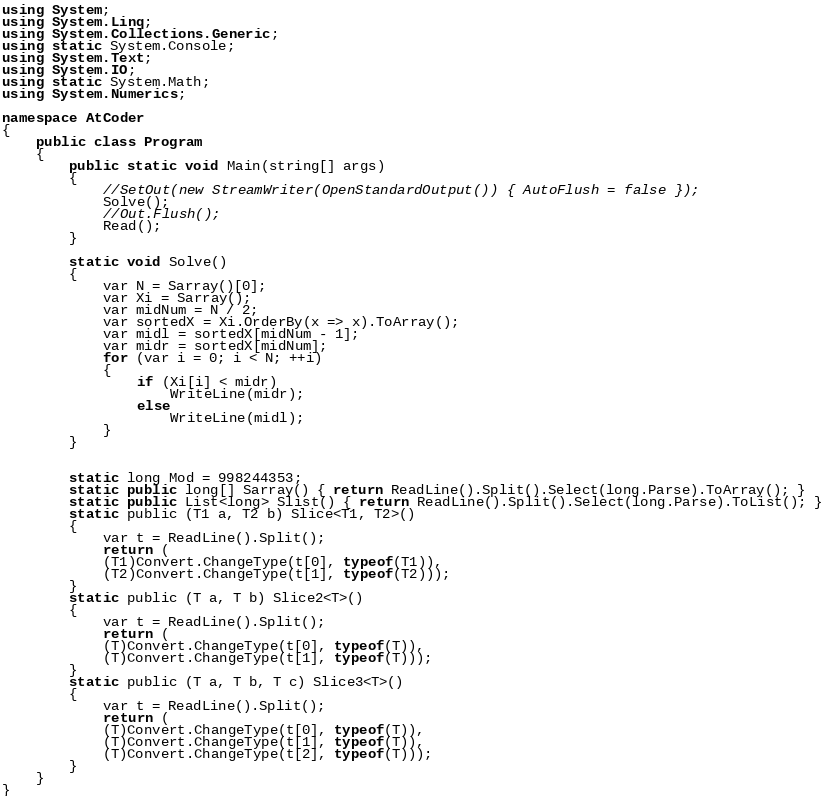<code> <loc_0><loc_0><loc_500><loc_500><_C#_>using System;
using System.Linq;
using System.Collections.Generic;
using static System.Console;
using System.Text;
using System.IO;
using static System.Math;
using System.Numerics;

namespace AtCoder
{
    public class Program
    {
        public static void Main(string[] args)
        {
            //SetOut(new StreamWriter(OpenStandardOutput()) { AutoFlush = false });
            Solve();
            //Out.Flush();
            Read();
        }

        static void Solve()
        {
            var N = Sarray()[0];
            var Xi = Sarray();
            var midNum = N / 2;
            var sortedX = Xi.OrderBy(x => x).ToArray();
            var midl = sortedX[midNum - 1];
            var midr = sortedX[midNum];
            for (var i = 0; i < N; ++i)
            {
                if (Xi[i] < midr)
                    WriteLine(midr);
                else
                    WriteLine(midl);
            }
        }


        static long Mod = 998244353;
        static public long[] Sarray() { return ReadLine().Split().Select(long.Parse).ToArray(); }
        static public List<long> Slist() { return ReadLine().Split().Select(long.Parse).ToList(); }
        static public (T1 a, T2 b) Slice<T1, T2>()
        {
            var t = ReadLine().Split();
            return (
            (T1)Convert.ChangeType(t[0], typeof(T1)),
            (T2)Convert.ChangeType(t[1], typeof(T2)));
        }
        static public (T a, T b) Slice2<T>()
        {
            var t = ReadLine().Split();
            return (
            (T)Convert.ChangeType(t[0], typeof(T)),
            (T)Convert.ChangeType(t[1], typeof(T)));
        }
        static public (T a, T b, T c) Slice3<T>()
        {
            var t = ReadLine().Split();
            return (
            (T)Convert.ChangeType(t[0], typeof(T)),
            (T)Convert.ChangeType(t[1], typeof(T)),
            (T)Convert.ChangeType(t[2], typeof(T)));
        }
    }
}</code> 